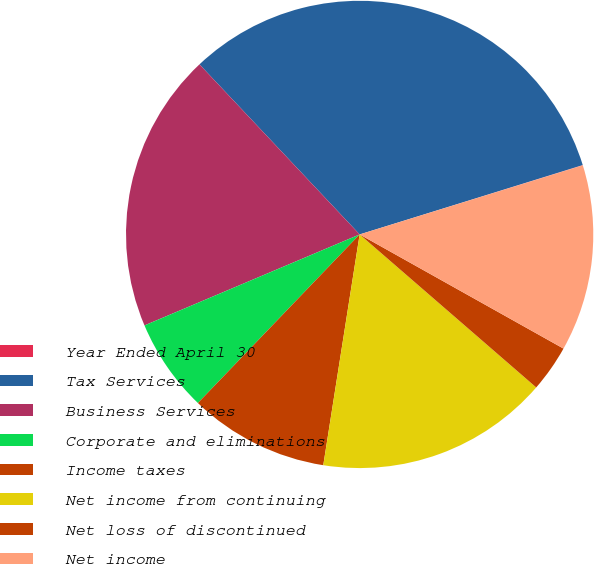Convert chart. <chart><loc_0><loc_0><loc_500><loc_500><pie_chart><fcel>Year Ended April 30<fcel>Tax Services<fcel>Business Services<fcel>Corporate and eliminations<fcel>Income taxes<fcel>Net income from continuing<fcel>Net loss of discontinued<fcel>Net income<nl><fcel>0.02%<fcel>32.22%<fcel>19.34%<fcel>6.46%<fcel>9.68%<fcel>16.12%<fcel>3.24%<fcel>12.9%<nl></chart> 